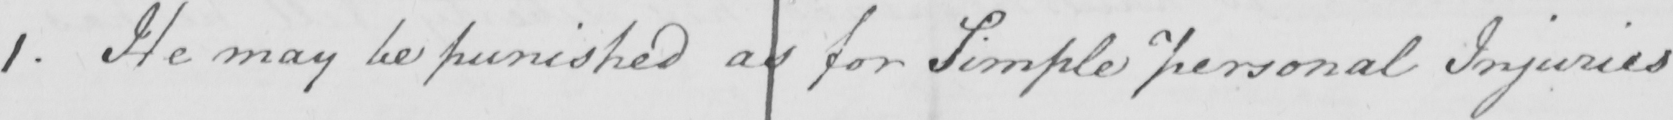Can you read and transcribe this handwriting? 1 . He may be punished as for Simple personal Injuries 